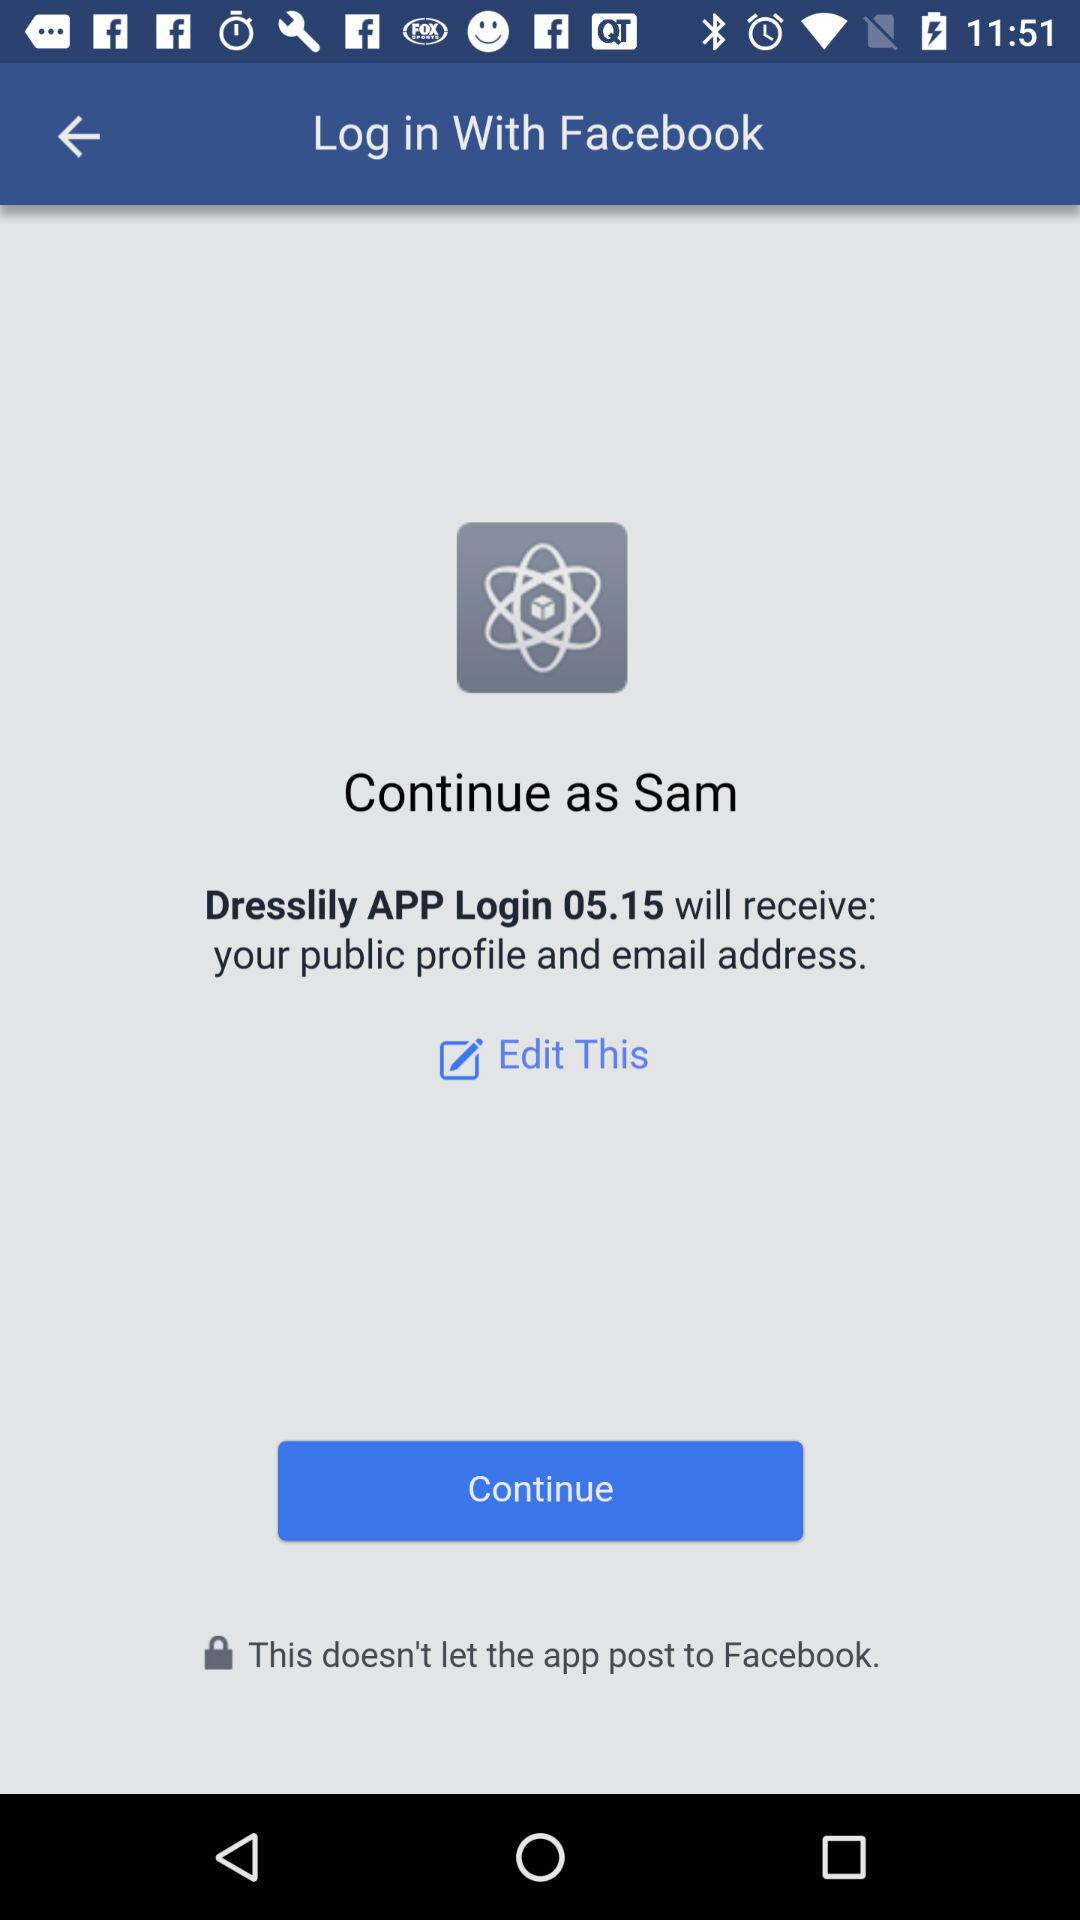How can we login? You can login through "Facebook". 